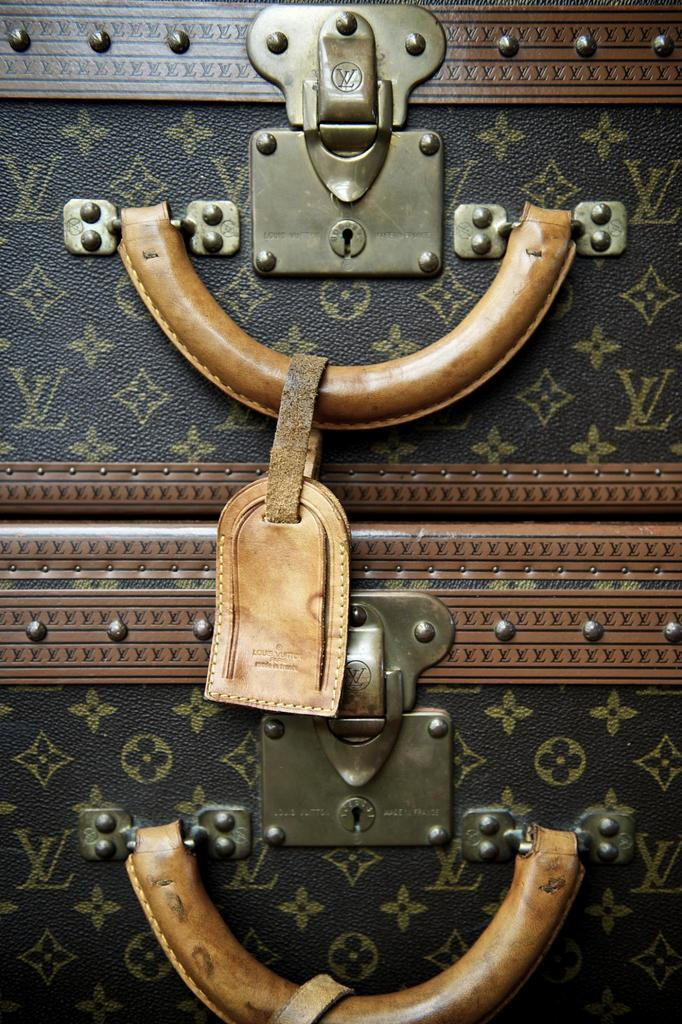How many suitcases are visible in the image? There are two suitcases in the image. What is the color of the suitcases? The suitcases are black in color. What feature do the suitcases have for carrying them? The suitcases have handles for carrying them. What is the color of the handles? The handles are brown in color. How are the suitcases secured? The suitcases have locks to secure them. What is the color of the locks? The locks are green in color. What religious symbol can be seen on the suitcases in the image? There is no religious symbol present on the suitcases in the image. How does the donkey help carry the suitcases in the image? There is no donkey present in the image to help carry the suitcases. 